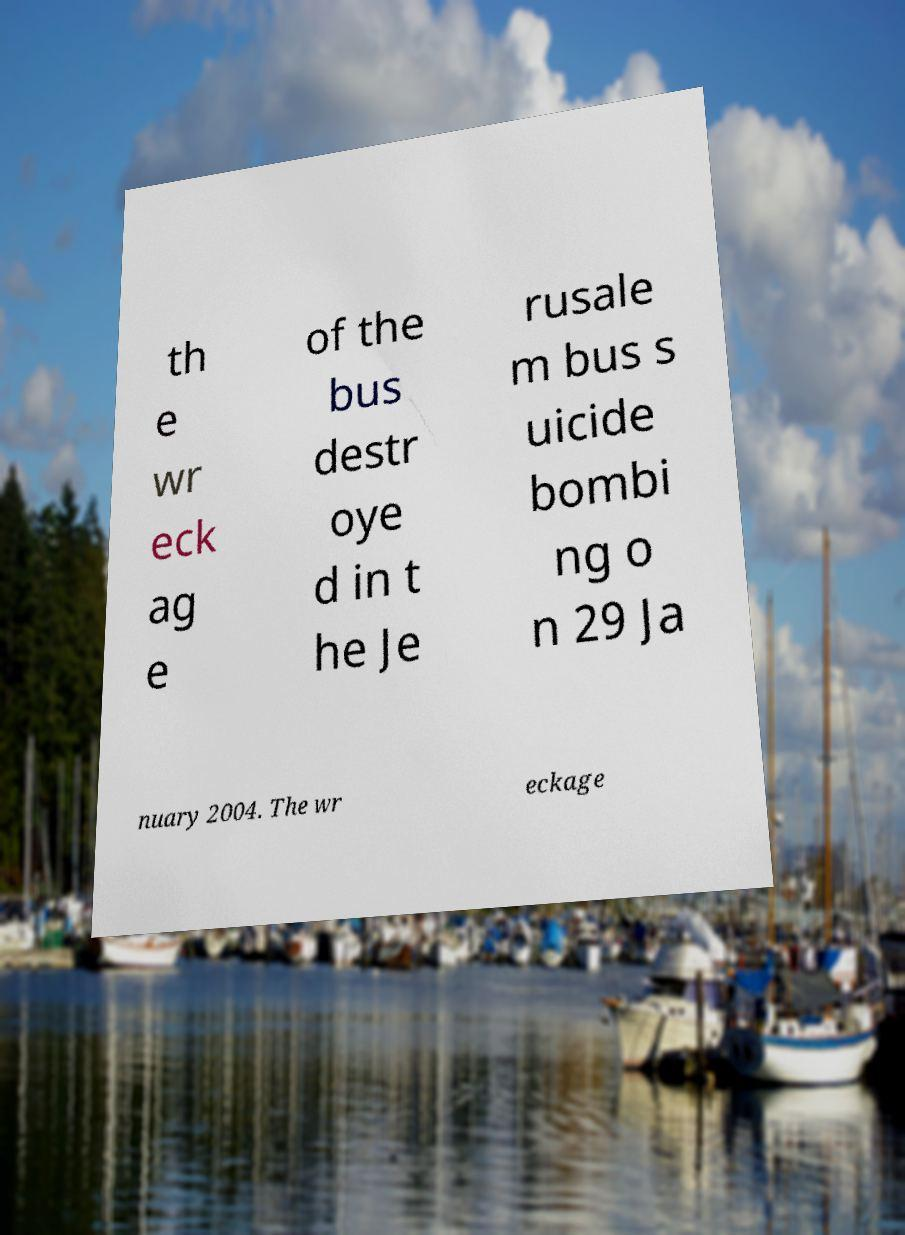Could you assist in decoding the text presented in this image and type it out clearly? th e wr eck ag e of the bus destr oye d in t he Je rusale m bus s uicide bombi ng o n 29 Ja nuary 2004. The wr eckage 